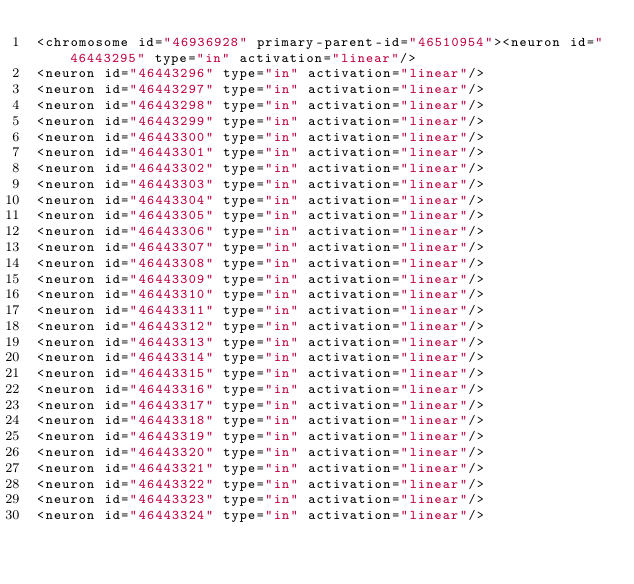<code> <loc_0><loc_0><loc_500><loc_500><_XML_><chromosome id="46936928" primary-parent-id="46510954"><neuron id="46443295" type="in" activation="linear"/>
<neuron id="46443296" type="in" activation="linear"/>
<neuron id="46443297" type="in" activation="linear"/>
<neuron id="46443298" type="in" activation="linear"/>
<neuron id="46443299" type="in" activation="linear"/>
<neuron id="46443300" type="in" activation="linear"/>
<neuron id="46443301" type="in" activation="linear"/>
<neuron id="46443302" type="in" activation="linear"/>
<neuron id="46443303" type="in" activation="linear"/>
<neuron id="46443304" type="in" activation="linear"/>
<neuron id="46443305" type="in" activation="linear"/>
<neuron id="46443306" type="in" activation="linear"/>
<neuron id="46443307" type="in" activation="linear"/>
<neuron id="46443308" type="in" activation="linear"/>
<neuron id="46443309" type="in" activation="linear"/>
<neuron id="46443310" type="in" activation="linear"/>
<neuron id="46443311" type="in" activation="linear"/>
<neuron id="46443312" type="in" activation="linear"/>
<neuron id="46443313" type="in" activation="linear"/>
<neuron id="46443314" type="in" activation="linear"/>
<neuron id="46443315" type="in" activation="linear"/>
<neuron id="46443316" type="in" activation="linear"/>
<neuron id="46443317" type="in" activation="linear"/>
<neuron id="46443318" type="in" activation="linear"/>
<neuron id="46443319" type="in" activation="linear"/>
<neuron id="46443320" type="in" activation="linear"/>
<neuron id="46443321" type="in" activation="linear"/>
<neuron id="46443322" type="in" activation="linear"/>
<neuron id="46443323" type="in" activation="linear"/>
<neuron id="46443324" type="in" activation="linear"/></code> 